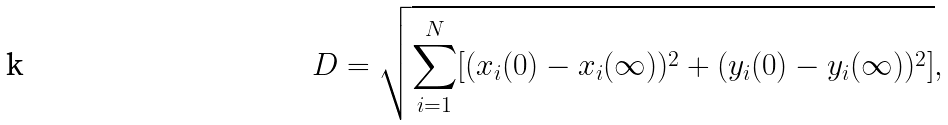Convert formula to latex. <formula><loc_0><loc_0><loc_500><loc_500>D = \sqrt { \sum _ { i = 1 } ^ { N } [ ( x _ { i } ( 0 ) - x _ { i } ( \infty ) ) ^ { 2 } + ( y _ { i } ( 0 ) - y _ { i } ( \infty ) ) ^ { 2 } ] } ,</formula> 